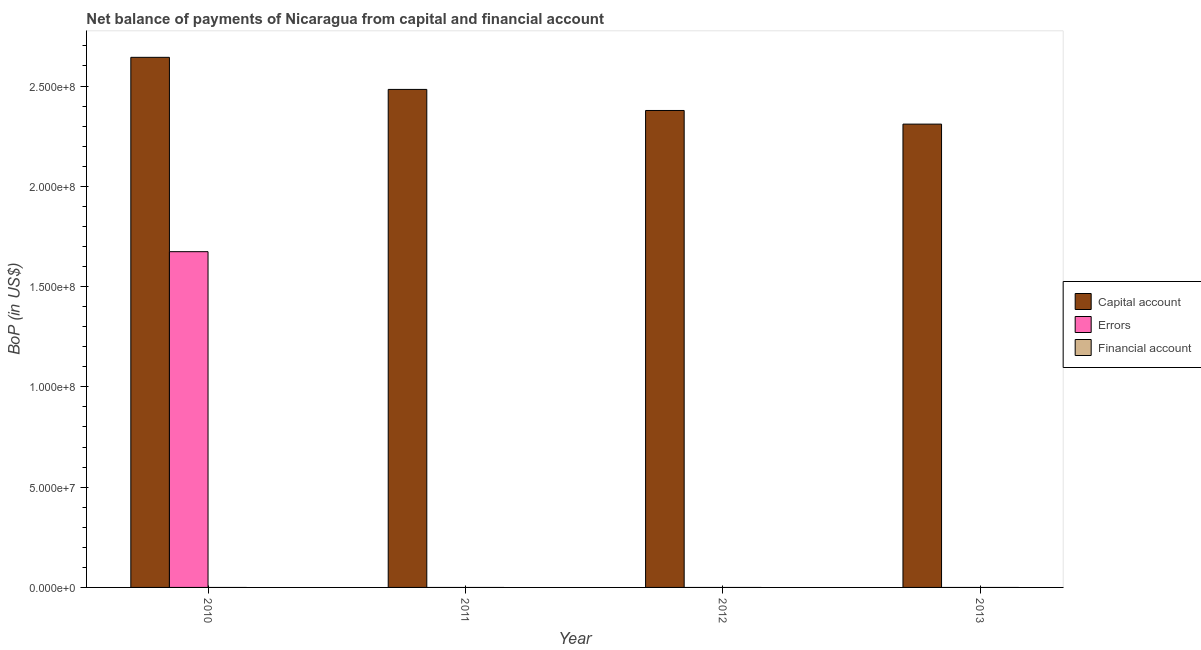Are the number of bars per tick equal to the number of legend labels?
Offer a terse response. No. Are the number of bars on each tick of the X-axis equal?
Provide a succinct answer. No. How many bars are there on the 2nd tick from the left?
Offer a terse response. 1. What is the amount of net capital account in 2010?
Offer a very short reply. 2.64e+08. Across all years, what is the maximum amount of errors?
Provide a short and direct response. 1.67e+08. Across all years, what is the minimum amount of errors?
Your answer should be compact. 0. In which year was the amount of errors maximum?
Your response must be concise. 2010. What is the total amount of net capital account in the graph?
Your answer should be compact. 9.81e+08. What is the difference between the amount of net capital account in 2010 and that in 2013?
Ensure brevity in your answer.  3.33e+07. What is the difference between the amount of net capital account in 2010 and the amount of errors in 2011?
Offer a very short reply. 1.60e+07. What is the average amount of financial account per year?
Ensure brevity in your answer.  0. In how many years, is the amount of financial account greater than 120000000 US$?
Keep it short and to the point. 0. Is the amount of net capital account in 2010 less than that in 2012?
Ensure brevity in your answer.  No. What is the difference between the highest and the second highest amount of net capital account?
Provide a short and direct response. 1.60e+07. What is the difference between the highest and the lowest amount of errors?
Ensure brevity in your answer.  1.67e+08. In how many years, is the amount of financial account greater than the average amount of financial account taken over all years?
Your answer should be compact. 0. Is the sum of the amount of net capital account in 2011 and 2012 greater than the maximum amount of errors across all years?
Make the answer very short. Yes. How many years are there in the graph?
Give a very brief answer. 4. What is the difference between two consecutive major ticks on the Y-axis?
Offer a very short reply. 5.00e+07. Does the graph contain any zero values?
Your response must be concise. Yes. Does the graph contain grids?
Offer a terse response. No. What is the title of the graph?
Make the answer very short. Net balance of payments of Nicaragua from capital and financial account. What is the label or title of the X-axis?
Your answer should be very brief. Year. What is the label or title of the Y-axis?
Provide a short and direct response. BoP (in US$). What is the BoP (in US$) of Capital account in 2010?
Give a very brief answer. 2.64e+08. What is the BoP (in US$) in Errors in 2010?
Offer a terse response. 1.67e+08. What is the BoP (in US$) of Financial account in 2010?
Offer a very short reply. 0. What is the BoP (in US$) in Capital account in 2011?
Your answer should be very brief. 2.48e+08. What is the BoP (in US$) in Errors in 2011?
Your response must be concise. 0. What is the BoP (in US$) of Capital account in 2012?
Provide a short and direct response. 2.38e+08. What is the BoP (in US$) in Errors in 2012?
Your response must be concise. 0. What is the BoP (in US$) in Capital account in 2013?
Make the answer very short. 2.31e+08. Across all years, what is the maximum BoP (in US$) of Capital account?
Ensure brevity in your answer.  2.64e+08. Across all years, what is the maximum BoP (in US$) in Errors?
Your answer should be very brief. 1.67e+08. Across all years, what is the minimum BoP (in US$) in Capital account?
Your answer should be compact. 2.31e+08. What is the total BoP (in US$) in Capital account in the graph?
Your response must be concise. 9.81e+08. What is the total BoP (in US$) in Errors in the graph?
Your answer should be very brief. 1.67e+08. What is the total BoP (in US$) of Financial account in the graph?
Keep it short and to the point. 0. What is the difference between the BoP (in US$) in Capital account in 2010 and that in 2011?
Your answer should be compact. 1.60e+07. What is the difference between the BoP (in US$) of Capital account in 2010 and that in 2012?
Make the answer very short. 2.65e+07. What is the difference between the BoP (in US$) in Capital account in 2010 and that in 2013?
Your answer should be compact. 3.33e+07. What is the difference between the BoP (in US$) of Capital account in 2011 and that in 2012?
Your response must be concise. 1.05e+07. What is the difference between the BoP (in US$) of Capital account in 2011 and that in 2013?
Ensure brevity in your answer.  1.73e+07. What is the difference between the BoP (in US$) of Capital account in 2012 and that in 2013?
Make the answer very short. 6.80e+06. What is the average BoP (in US$) of Capital account per year?
Provide a succinct answer. 2.45e+08. What is the average BoP (in US$) of Errors per year?
Your answer should be compact. 4.18e+07. In the year 2010, what is the difference between the BoP (in US$) in Capital account and BoP (in US$) in Errors?
Provide a short and direct response. 9.69e+07. What is the ratio of the BoP (in US$) of Capital account in 2010 to that in 2011?
Your response must be concise. 1.06. What is the ratio of the BoP (in US$) of Capital account in 2010 to that in 2012?
Your answer should be compact. 1.11. What is the ratio of the BoP (in US$) of Capital account in 2010 to that in 2013?
Your response must be concise. 1.14. What is the ratio of the BoP (in US$) of Capital account in 2011 to that in 2012?
Make the answer very short. 1.04. What is the ratio of the BoP (in US$) in Capital account in 2011 to that in 2013?
Keep it short and to the point. 1.07. What is the ratio of the BoP (in US$) of Capital account in 2012 to that in 2013?
Your answer should be compact. 1.03. What is the difference between the highest and the second highest BoP (in US$) in Capital account?
Give a very brief answer. 1.60e+07. What is the difference between the highest and the lowest BoP (in US$) in Capital account?
Your answer should be compact. 3.33e+07. What is the difference between the highest and the lowest BoP (in US$) in Errors?
Make the answer very short. 1.67e+08. 